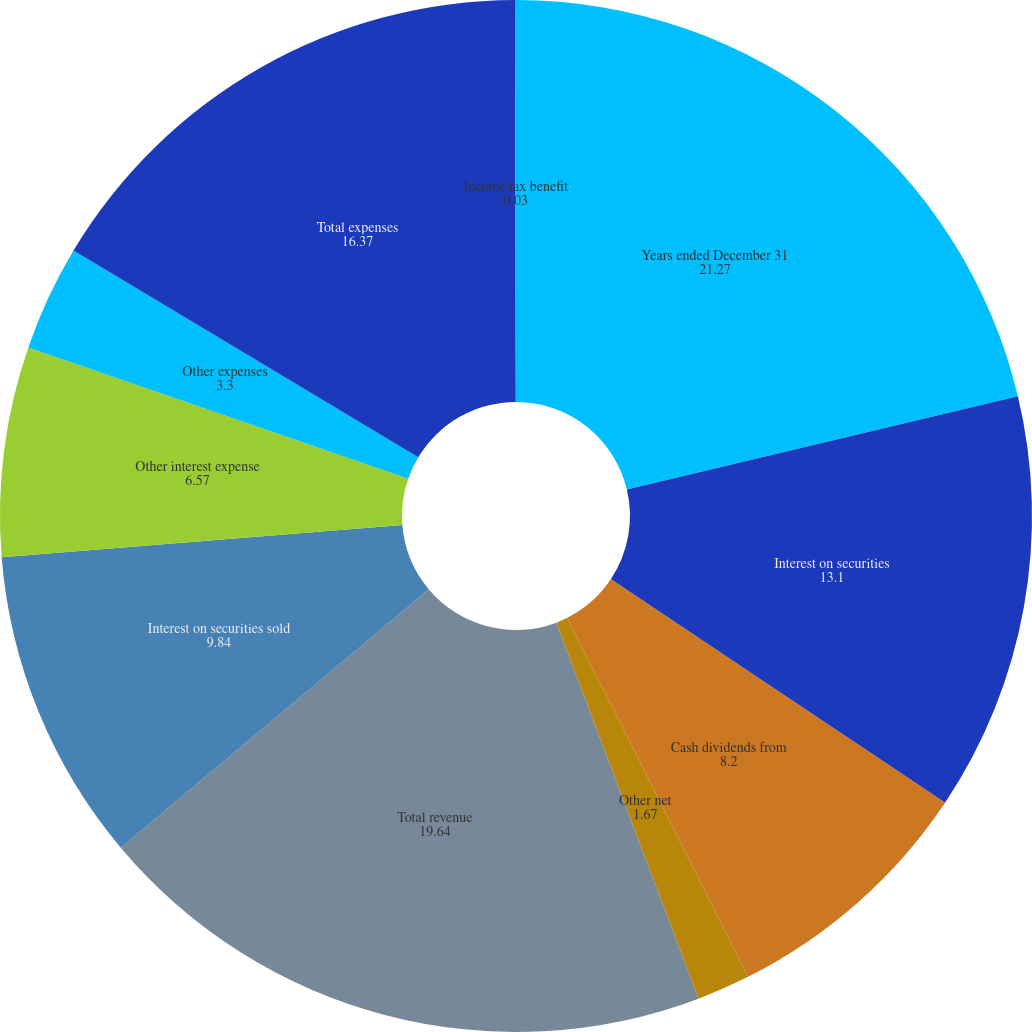Convert chart. <chart><loc_0><loc_0><loc_500><loc_500><pie_chart><fcel>Years ended December 31<fcel>Interest on securities<fcel>Cash dividends from<fcel>Other net<fcel>Total revenue<fcel>Interest on securities sold<fcel>Other interest expense<fcel>Other expenses<fcel>Total expenses<fcel>Income tax benefit<nl><fcel>21.27%<fcel>13.1%<fcel>8.2%<fcel>1.67%<fcel>19.64%<fcel>9.84%<fcel>6.57%<fcel>3.3%<fcel>16.37%<fcel>0.03%<nl></chart> 